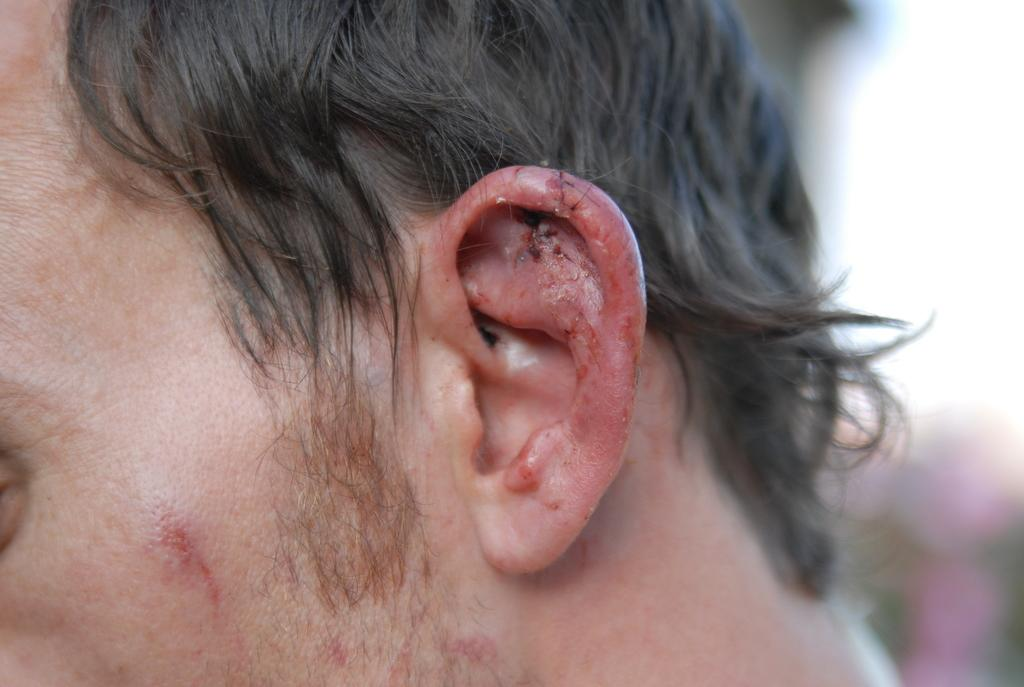What is present in the image? There is a person in the image. What part of the person's body can be seen? The person's ear and hair are visible. Is there any indication of an injury or medical issue in the image? Yes, blood is coming out of the person's ear. What type of pest can be seen crawling on the person's hair in the image? There are no pests visible in the image; only the person's hair is present. How many birds are perched on the person's shoulder in the image? There are no birds present in the image; only the person is visible. 